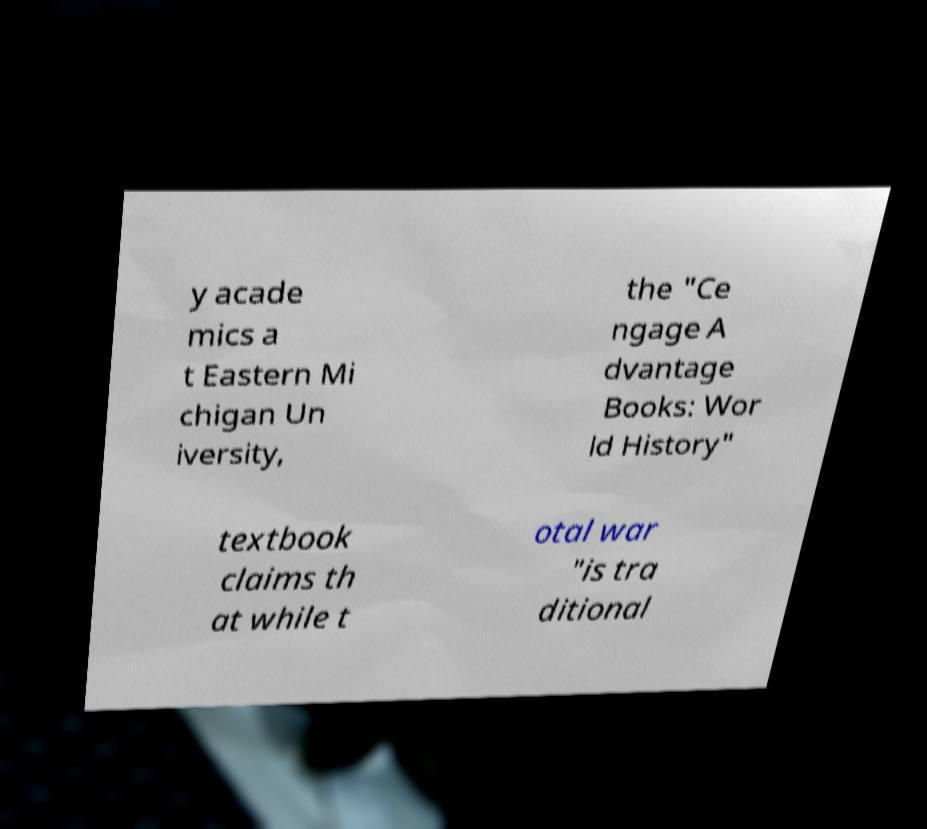There's text embedded in this image that I need extracted. Can you transcribe it verbatim? y acade mics a t Eastern Mi chigan Un iversity, the "Ce ngage A dvantage Books: Wor ld History" textbook claims th at while t otal war "is tra ditional 